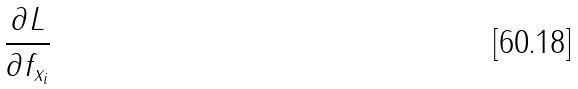<formula> <loc_0><loc_0><loc_500><loc_500>\frac { \partial L } { \partial f _ { x _ { i } } }</formula> 